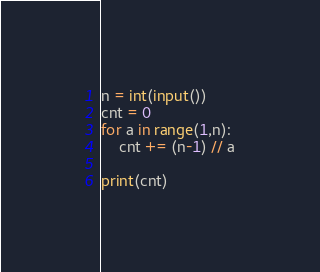<code> <loc_0><loc_0><loc_500><loc_500><_Python_>n = int(input())
cnt = 0
for a in range(1,n):
    cnt += (n-1) // a
    
print(cnt)</code> 